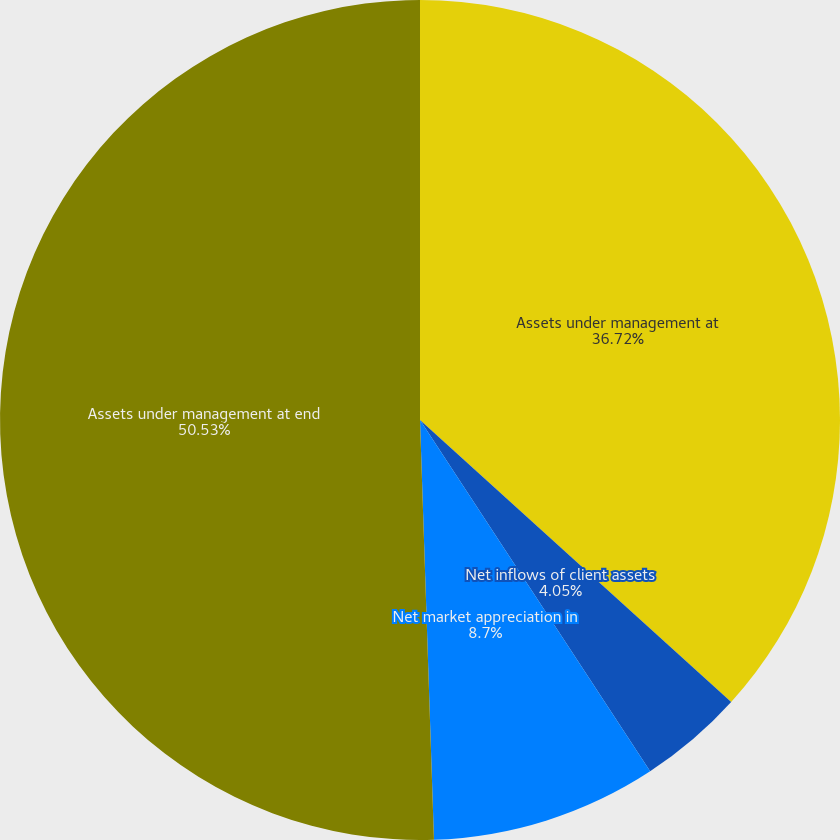<chart> <loc_0><loc_0><loc_500><loc_500><pie_chart><fcel>Assets under management at<fcel>Net inflows of client assets<fcel>Net market appreciation in<fcel>Assets under management at end<nl><fcel>36.72%<fcel>4.05%<fcel>8.7%<fcel>50.53%<nl></chart> 